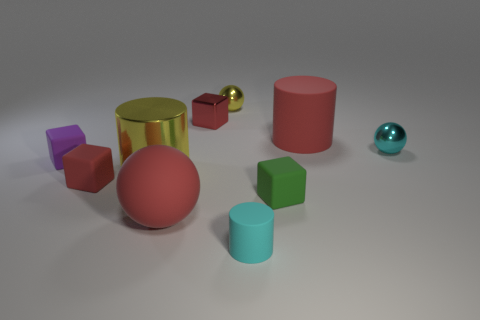Are there any small rubber cubes behind the red cylinder?
Your answer should be compact. No. How many yellow objects are right of the tiny object that is right of the green matte thing?
Make the answer very short. 0. There is another cylinder that is the same size as the red matte cylinder; what is it made of?
Provide a succinct answer. Metal. What number of other objects are the same material as the big yellow cylinder?
Your response must be concise. 3. What number of big yellow metal things are left of the purple object?
Your response must be concise. 0. How many balls are either purple rubber objects or green objects?
Offer a terse response. 0. How big is the red rubber thing that is both behind the rubber sphere and right of the big metallic cylinder?
Your response must be concise. Large. What number of other objects are there of the same color as the tiny shiny block?
Give a very brief answer. 3. Does the big red cylinder have the same material as the purple cube behind the red sphere?
Offer a terse response. Yes. What number of things are either small red metal cubes that are behind the small cyan matte cylinder or small metal blocks?
Your answer should be compact. 1. 